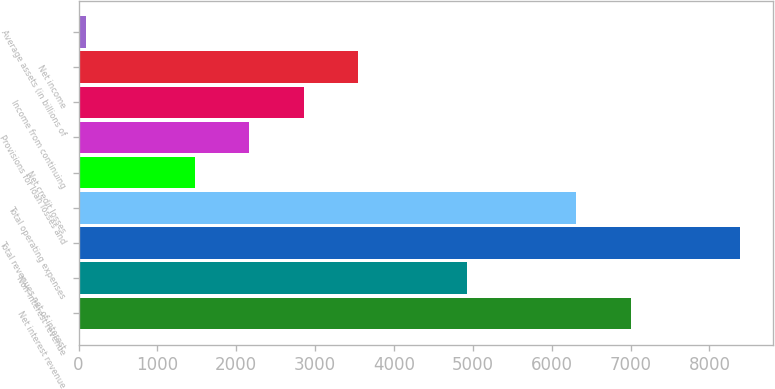<chart> <loc_0><loc_0><loc_500><loc_500><bar_chart><fcel>Net interest revenue<fcel>Non-interest revenue<fcel>Total revenues net of interest<fcel>Total operating expenses<fcel>Net credit losses<fcel>Provisions for loan losses and<fcel>Income from continuing<fcel>Net income<fcel>Average assets (in billions of<nl><fcel>7004<fcel>4929.2<fcel>8387.2<fcel>6312.4<fcel>1471.2<fcel>2162.8<fcel>2854.4<fcel>3546<fcel>88<nl></chart> 